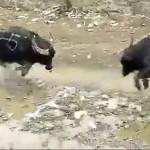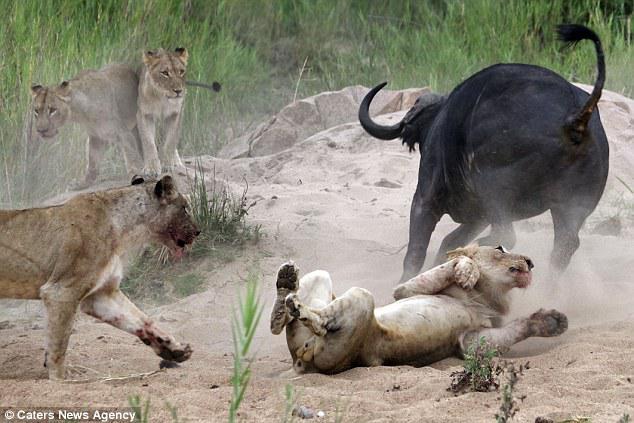The first image is the image on the left, the second image is the image on the right. Considering the images on both sides, is "In one of the images the animals are in the wild." valid? Answer yes or no. Yes. The first image is the image on the left, the second image is the image on the right. Assess this claim about the two images: "There are four animals in total in the image pair.". Correct or not? Answer yes or no. No. 